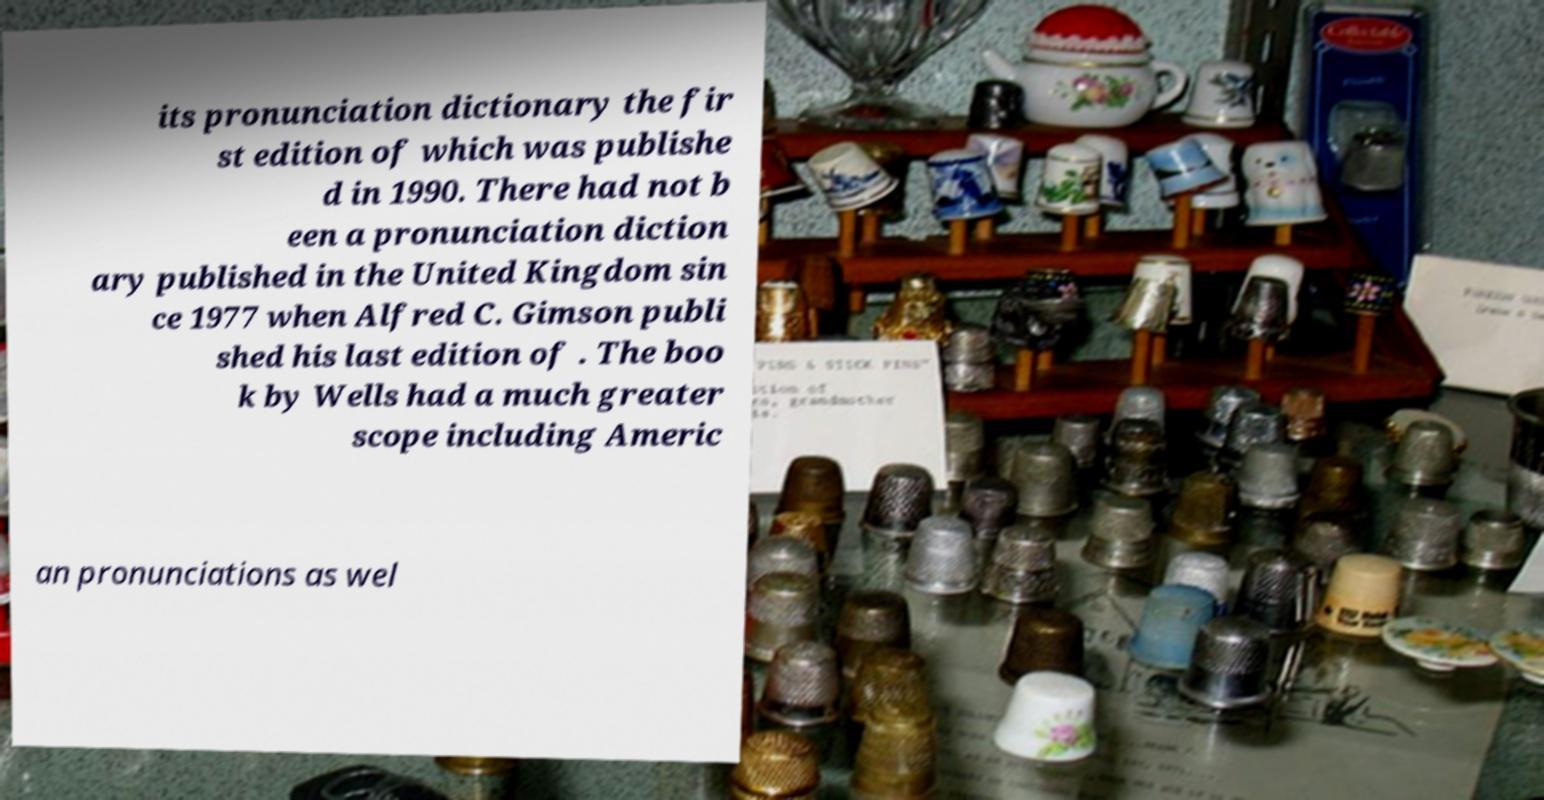There's text embedded in this image that I need extracted. Can you transcribe it verbatim? its pronunciation dictionary the fir st edition of which was publishe d in 1990. There had not b een a pronunciation diction ary published in the United Kingdom sin ce 1977 when Alfred C. Gimson publi shed his last edition of . The boo k by Wells had a much greater scope including Americ an pronunciations as wel 